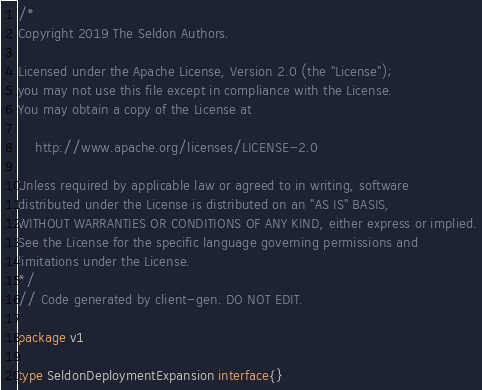<code> <loc_0><loc_0><loc_500><loc_500><_Go_>/*
Copyright 2019 The Seldon Authors.

Licensed under the Apache License, Version 2.0 (the "License");
you may not use this file except in compliance with the License.
You may obtain a copy of the License at

    http://www.apache.org/licenses/LICENSE-2.0

Unless required by applicable law or agreed to in writing, software
distributed under the License is distributed on an "AS IS" BASIS,
WITHOUT WARRANTIES OR CONDITIONS OF ANY KIND, either express or implied.
See the License for the specific language governing permissions and
limitations under the License.
*/
// Code generated by client-gen. DO NOT EDIT.

package v1

type SeldonDeploymentExpansion interface{}
</code> 